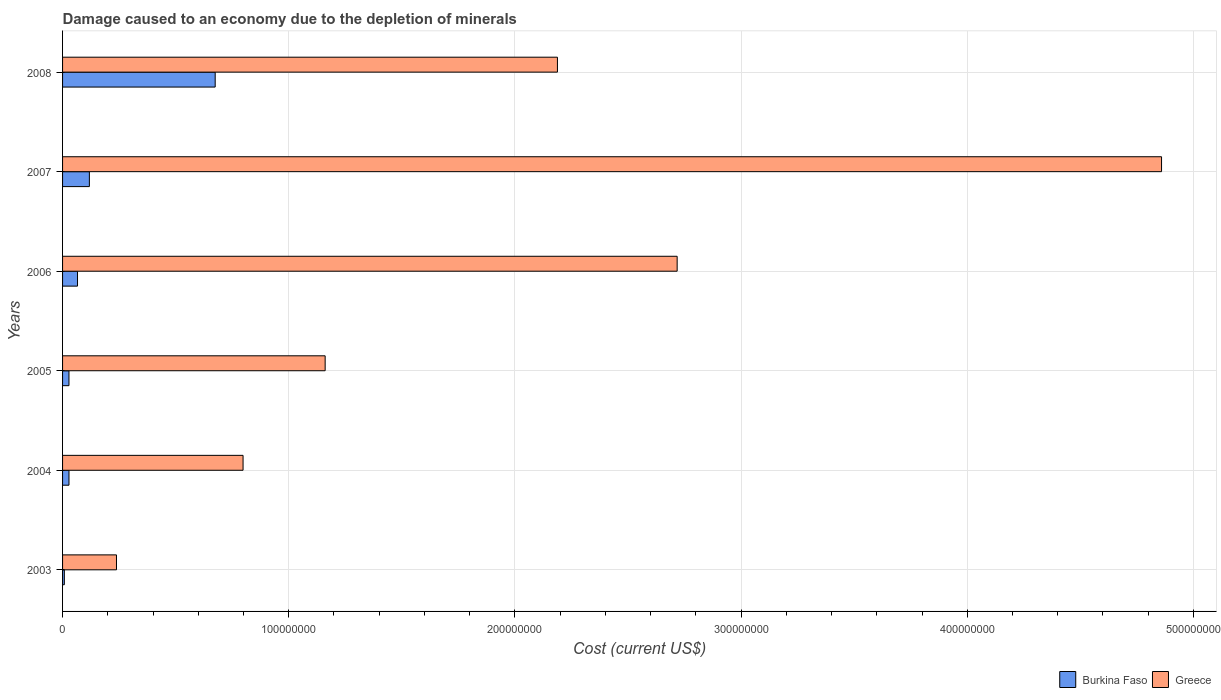Are the number of bars per tick equal to the number of legend labels?
Give a very brief answer. Yes. Are the number of bars on each tick of the Y-axis equal?
Provide a short and direct response. Yes. How many bars are there on the 6th tick from the top?
Keep it short and to the point. 2. How many bars are there on the 3rd tick from the bottom?
Ensure brevity in your answer.  2. In how many cases, is the number of bars for a given year not equal to the number of legend labels?
Ensure brevity in your answer.  0. What is the cost of damage caused due to the depletion of minerals in Greece in 2005?
Provide a succinct answer. 1.16e+08. Across all years, what is the maximum cost of damage caused due to the depletion of minerals in Burkina Faso?
Keep it short and to the point. 6.75e+07. Across all years, what is the minimum cost of damage caused due to the depletion of minerals in Greece?
Make the answer very short. 2.38e+07. What is the total cost of damage caused due to the depletion of minerals in Greece in the graph?
Your answer should be very brief. 1.20e+09. What is the difference between the cost of damage caused due to the depletion of minerals in Greece in 2005 and that in 2007?
Make the answer very short. -3.70e+08. What is the difference between the cost of damage caused due to the depletion of minerals in Burkina Faso in 2007 and the cost of damage caused due to the depletion of minerals in Greece in 2003?
Your answer should be compact. -1.20e+07. What is the average cost of damage caused due to the depletion of minerals in Burkina Faso per year?
Ensure brevity in your answer.  1.54e+07. In the year 2006, what is the difference between the cost of damage caused due to the depletion of minerals in Greece and cost of damage caused due to the depletion of minerals in Burkina Faso?
Ensure brevity in your answer.  2.65e+08. What is the ratio of the cost of damage caused due to the depletion of minerals in Burkina Faso in 2003 to that in 2006?
Make the answer very short. 0.12. Is the cost of damage caused due to the depletion of minerals in Burkina Faso in 2005 less than that in 2007?
Provide a short and direct response. Yes. What is the difference between the highest and the second highest cost of damage caused due to the depletion of minerals in Greece?
Offer a terse response. 2.14e+08. What is the difference between the highest and the lowest cost of damage caused due to the depletion of minerals in Burkina Faso?
Provide a short and direct response. 6.67e+07. Is the sum of the cost of damage caused due to the depletion of minerals in Burkina Faso in 2003 and 2005 greater than the maximum cost of damage caused due to the depletion of minerals in Greece across all years?
Keep it short and to the point. No. What does the 2nd bar from the top in 2003 represents?
Your answer should be very brief. Burkina Faso. Are all the bars in the graph horizontal?
Offer a very short reply. Yes. How many years are there in the graph?
Ensure brevity in your answer.  6. What is the difference between two consecutive major ticks on the X-axis?
Keep it short and to the point. 1.00e+08. Does the graph contain any zero values?
Your answer should be compact. No. How many legend labels are there?
Keep it short and to the point. 2. What is the title of the graph?
Offer a very short reply. Damage caused to an economy due to the depletion of minerals. Does "Indonesia" appear as one of the legend labels in the graph?
Give a very brief answer. No. What is the label or title of the X-axis?
Give a very brief answer. Cost (current US$). What is the label or title of the Y-axis?
Offer a very short reply. Years. What is the Cost (current US$) in Burkina Faso in 2003?
Provide a succinct answer. 7.84e+05. What is the Cost (current US$) of Greece in 2003?
Ensure brevity in your answer.  2.38e+07. What is the Cost (current US$) of Burkina Faso in 2004?
Provide a succinct answer. 2.83e+06. What is the Cost (current US$) in Greece in 2004?
Your answer should be very brief. 7.98e+07. What is the Cost (current US$) in Burkina Faso in 2005?
Give a very brief answer. 2.83e+06. What is the Cost (current US$) of Greece in 2005?
Your answer should be compact. 1.16e+08. What is the Cost (current US$) in Burkina Faso in 2006?
Your response must be concise. 6.61e+06. What is the Cost (current US$) of Greece in 2006?
Offer a terse response. 2.72e+08. What is the Cost (current US$) in Burkina Faso in 2007?
Make the answer very short. 1.19e+07. What is the Cost (current US$) in Greece in 2007?
Provide a short and direct response. 4.86e+08. What is the Cost (current US$) of Burkina Faso in 2008?
Ensure brevity in your answer.  6.75e+07. What is the Cost (current US$) of Greece in 2008?
Keep it short and to the point. 2.19e+08. Across all years, what is the maximum Cost (current US$) in Burkina Faso?
Your answer should be very brief. 6.75e+07. Across all years, what is the maximum Cost (current US$) of Greece?
Make the answer very short. 4.86e+08. Across all years, what is the minimum Cost (current US$) of Burkina Faso?
Offer a very short reply. 7.84e+05. Across all years, what is the minimum Cost (current US$) in Greece?
Keep it short and to the point. 2.38e+07. What is the total Cost (current US$) in Burkina Faso in the graph?
Your answer should be compact. 9.24e+07. What is the total Cost (current US$) in Greece in the graph?
Offer a very short reply. 1.20e+09. What is the difference between the Cost (current US$) in Burkina Faso in 2003 and that in 2004?
Provide a short and direct response. -2.05e+06. What is the difference between the Cost (current US$) in Greece in 2003 and that in 2004?
Your answer should be very brief. -5.60e+07. What is the difference between the Cost (current US$) in Burkina Faso in 2003 and that in 2005?
Your response must be concise. -2.05e+06. What is the difference between the Cost (current US$) in Greece in 2003 and that in 2005?
Offer a very short reply. -9.23e+07. What is the difference between the Cost (current US$) in Burkina Faso in 2003 and that in 2006?
Give a very brief answer. -5.83e+06. What is the difference between the Cost (current US$) of Greece in 2003 and that in 2006?
Give a very brief answer. -2.48e+08. What is the difference between the Cost (current US$) of Burkina Faso in 2003 and that in 2007?
Provide a succinct answer. -1.11e+07. What is the difference between the Cost (current US$) in Greece in 2003 and that in 2007?
Keep it short and to the point. -4.62e+08. What is the difference between the Cost (current US$) in Burkina Faso in 2003 and that in 2008?
Your answer should be very brief. -6.67e+07. What is the difference between the Cost (current US$) of Greece in 2003 and that in 2008?
Ensure brevity in your answer.  -1.95e+08. What is the difference between the Cost (current US$) in Burkina Faso in 2004 and that in 2005?
Provide a short and direct response. 3403.93. What is the difference between the Cost (current US$) in Greece in 2004 and that in 2005?
Make the answer very short. -3.63e+07. What is the difference between the Cost (current US$) in Burkina Faso in 2004 and that in 2006?
Your answer should be very brief. -3.78e+06. What is the difference between the Cost (current US$) in Greece in 2004 and that in 2006?
Make the answer very short. -1.92e+08. What is the difference between the Cost (current US$) of Burkina Faso in 2004 and that in 2007?
Give a very brief answer. -9.02e+06. What is the difference between the Cost (current US$) of Greece in 2004 and that in 2007?
Offer a terse response. -4.06e+08. What is the difference between the Cost (current US$) of Burkina Faso in 2004 and that in 2008?
Your answer should be very brief. -6.46e+07. What is the difference between the Cost (current US$) in Greece in 2004 and that in 2008?
Provide a succinct answer. -1.39e+08. What is the difference between the Cost (current US$) of Burkina Faso in 2005 and that in 2006?
Make the answer very short. -3.78e+06. What is the difference between the Cost (current US$) in Greece in 2005 and that in 2006?
Keep it short and to the point. -1.56e+08. What is the difference between the Cost (current US$) in Burkina Faso in 2005 and that in 2007?
Give a very brief answer. -9.02e+06. What is the difference between the Cost (current US$) of Greece in 2005 and that in 2007?
Keep it short and to the point. -3.70e+08. What is the difference between the Cost (current US$) in Burkina Faso in 2005 and that in 2008?
Provide a short and direct response. -6.47e+07. What is the difference between the Cost (current US$) of Greece in 2005 and that in 2008?
Make the answer very short. -1.03e+08. What is the difference between the Cost (current US$) in Burkina Faso in 2006 and that in 2007?
Your answer should be compact. -5.24e+06. What is the difference between the Cost (current US$) of Greece in 2006 and that in 2007?
Provide a short and direct response. -2.14e+08. What is the difference between the Cost (current US$) of Burkina Faso in 2006 and that in 2008?
Provide a succinct answer. -6.09e+07. What is the difference between the Cost (current US$) of Greece in 2006 and that in 2008?
Offer a terse response. 5.29e+07. What is the difference between the Cost (current US$) in Burkina Faso in 2007 and that in 2008?
Your answer should be very brief. -5.56e+07. What is the difference between the Cost (current US$) in Greece in 2007 and that in 2008?
Offer a very short reply. 2.67e+08. What is the difference between the Cost (current US$) of Burkina Faso in 2003 and the Cost (current US$) of Greece in 2004?
Give a very brief answer. -7.90e+07. What is the difference between the Cost (current US$) of Burkina Faso in 2003 and the Cost (current US$) of Greece in 2005?
Ensure brevity in your answer.  -1.15e+08. What is the difference between the Cost (current US$) of Burkina Faso in 2003 and the Cost (current US$) of Greece in 2006?
Your answer should be very brief. -2.71e+08. What is the difference between the Cost (current US$) of Burkina Faso in 2003 and the Cost (current US$) of Greece in 2007?
Provide a short and direct response. -4.85e+08. What is the difference between the Cost (current US$) in Burkina Faso in 2003 and the Cost (current US$) in Greece in 2008?
Your response must be concise. -2.18e+08. What is the difference between the Cost (current US$) of Burkina Faso in 2004 and the Cost (current US$) of Greece in 2005?
Offer a very short reply. -1.13e+08. What is the difference between the Cost (current US$) of Burkina Faso in 2004 and the Cost (current US$) of Greece in 2006?
Provide a succinct answer. -2.69e+08. What is the difference between the Cost (current US$) of Burkina Faso in 2004 and the Cost (current US$) of Greece in 2007?
Provide a short and direct response. -4.83e+08. What is the difference between the Cost (current US$) in Burkina Faso in 2004 and the Cost (current US$) in Greece in 2008?
Your answer should be compact. -2.16e+08. What is the difference between the Cost (current US$) in Burkina Faso in 2005 and the Cost (current US$) in Greece in 2006?
Make the answer very short. -2.69e+08. What is the difference between the Cost (current US$) of Burkina Faso in 2005 and the Cost (current US$) of Greece in 2007?
Your answer should be very brief. -4.83e+08. What is the difference between the Cost (current US$) in Burkina Faso in 2005 and the Cost (current US$) in Greece in 2008?
Keep it short and to the point. -2.16e+08. What is the difference between the Cost (current US$) in Burkina Faso in 2006 and the Cost (current US$) in Greece in 2007?
Ensure brevity in your answer.  -4.79e+08. What is the difference between the Cost (current US$) of Burkina Faso in 2006 and the Cost (current US$) of Greece in 2008?
Provide a short and direct response. -2.12e+08. What is the difference between the Cost (current US$) in Burkina Faso in 2007 and the Cost (current US$) in Greece in 2008?
Make the answer very short. -2.07e+08. What is the average Cost (current US$) in Burkina Faso per year?
Make the answer very short. 1.54e+07. What is the average Cost (current US$) of Greece per year?
Keep it short and to the point. 1.99e+08. In the year 2003, what is the difference between the Cost (current US$) of Burkina Faso and Cost (current US$) of Greece?
Ensure brevity in your answer.  -2.31e+07. In the year 2004, what is the difference between the Cost (current US$) of Burkina Faso and Cost (current US$) of Greece?
Offer a terse response. -7.70e+07. In the year 2005, what is the difference between the Cost (current US$) in Burkina Faso and Cost (current US$) in Greece?
Keep it short and to the point. -1.13e+08. In the year 2006, what is the difference between the Cost (current US$) in Burkina Faso and Cost (current US$) in Greece?
Offer a very short reply. -2.65e+08. In the year 2007, what is the difference between the Cost (current US$) in Burkina Faso and Cost (current US$) in Greece?
Make the answer very short. -4.74e+08. In the year 2008, what is the difference between the Cost (current US$) of Burkina Faso and Cost (current US$) of Greece?
Give a very brief answer. -1.51e+08. What is the ratio of the Cost (current US$) in Burkina Faso in 2003 to that in 2004?
Give a very brief answer. 0.28. What is the ratio of the Cost (current US$) of Greece in 2003 to that in 2004?
Provide a succinct answer. 0.3. What is the ratio of the Cost (current US$) of Burkina Faso in 2003 to that in 2005?
Your response must be concise. 0.28. What is the ratio of the Cost (current US$) of Greece in 2003 to that in 2005?
Your answer should be compact. 0.21. What is the ratio of the Cost (current US$) of Burkina Faso in 2003 to that in 2006?
Your answer should be very brief. 0.12. What is the ratio of the Cost (current US$) in Greece in 2003 to that in 2006?
Keep it short and to the point. 0.09. What is the ratio of the Cost (current US$) of Burkina Faso in 2003 to that in 2007?
Your answer should be compact. 0.07. What is the ratio of the Cost (current US$) in Greece in 2003 to that in 2007?
Provide a succinct answer. 0.05. What is the ratio of the Cost (current US$) in Burkina Faso in 2003 to that in 2008?
Keep it short and to the point. 0.01. What is the ratio of the Cost (current US$) in Greece in 2003 to that in 2008?
Your answer should be compact. 0.11. What is the ratio of the Cost (current US$) in Greece in 2004 to that in 2005?
Your response must be concise. 0.69. What is the ratio of the Cost (current US$) in Burkina Faso in 2004 to that in 2006?
Make the answer very short. 0.43. What is the ratio of the Cost (current US$) in Greece in 2004 to that in 2006?
Ensure brevity in your answer.  0.29. What is the ratio of the Cost (current US$) of Burkina Faso in 2004 to that in 2007?
Your response must be concise. 0.24. What is the ratio of the Cost (current US$) of Greece in 2004 to that in 2007?
Make the answer very short. 0.16. What is the ratio of the Cost (current US$) of Burkina Faso in 2004 to that in 2008?
Offer a very short reply. 0.04. What is the ratio of the Cost (current US$) in Greece in 2004 to that in 2008?
Ensure brevity in your answer.  0.36. What is the ratio of the Cost (current US$) of Burkina Faso in 2005 to that in 2006?
Provide a short and direct response. 0.43. What is the ratio of the Cost (current US$) in Greece in 2005 to that in 2006?
Offer a very short reply. 0.43. What is the ratio of the Cost (current US$) in Burkina Faso in 2005 to that in 2007?
Make the answer very short. 0.24. What is the ratio of the Cost (current US$) in Greece in 2005 to that in 2007?
Ensure brevity in your answer.  0.24. What is the ratio of the Cost (current US$) in Burkina Faso in 2005 to that in 2008?
Give a very brief answer. 0.04. What is the ratio of the Cost (current US$) of Greece in 2005 to that in 2008?
Offer a very short reply. 0.53. What is the ratio of the Cost (current US$) in Burkina Faso in 2006 to that in 2007?
Your response must be concise. 0.56. What is the ratio of the Cost (current US$) of Greece in 2006 to that in 2007?
Ensure brevity in your answer.  0.56. What is the ratio of the Cost (current US$) of Burkina Faso in 2006 to that in 2008?
Offer a very short reply. 0.1. What is the ratio of the Cost (current US$) in Greece in 2006 to that in 2008?
Your answer should be very brief. 1.24. What is the ratio of the Cost (current US$) of Burkina Faso in 2007 to that in 2008?
Make the answer very short. 0.18. What is the ratio of the Cost (current US$) of Greece in 2007 to that in 2008?
Offer a very short reply. 2.22. What is the difference between the highest and the second highest Cost (current US$) of Burkina Faso?
Make the answer very short. 5.56e+07. What is the difference between the highest and the second highest Cost (current US$) of Greece?
Your answer should be compact. 2.14e+08. What is the difference between the highest and the lowest Cost (current US$) of Burkina Faso?
Offer a very short reply. 6.67e+07. What is the difference between the highest and the lowest Cost (current US$) in Greece?
Provide a succinct answer. 4.62e+08. 